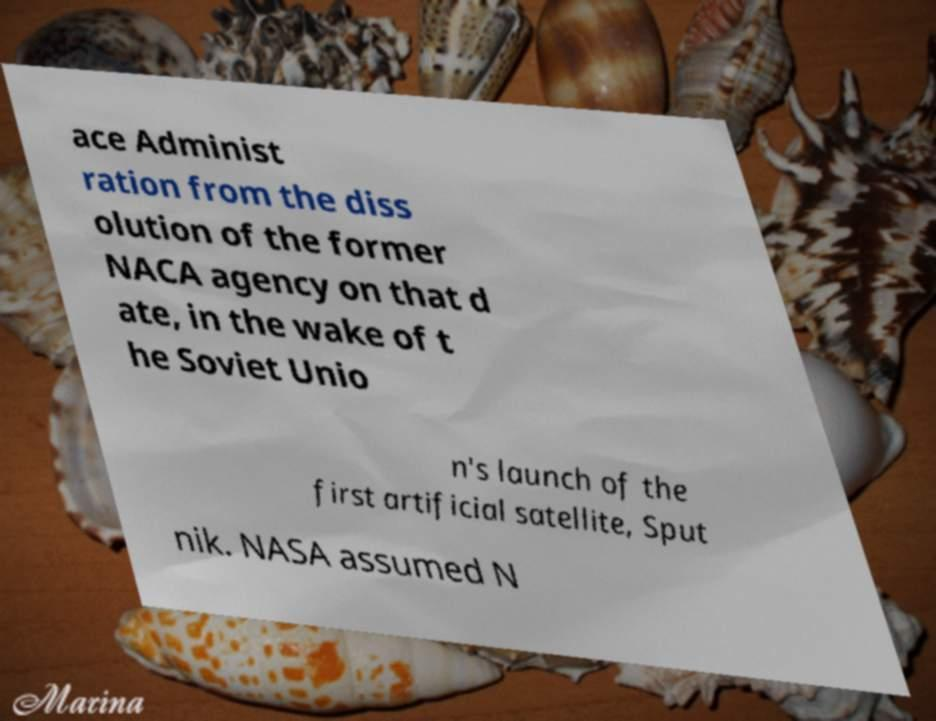Can you read and provide the text displayed in the image?This photo seems to have some interesting text. Can you extract and type it out for me? ace Administ ration from the diss olution of the former NACA agency on that d ate, in the wake of t he Soviet Unio n's launch of the first artificial satellite, Sput nik. NASA assumed N 